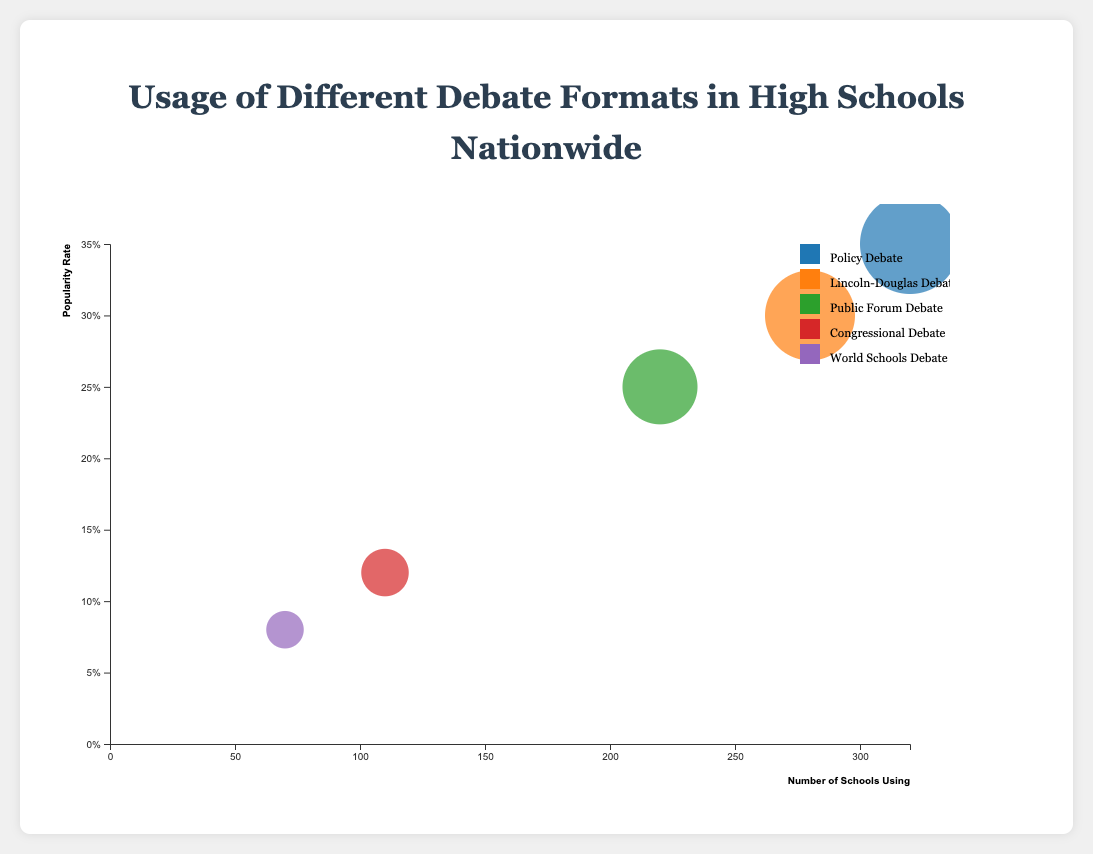What is the title of the bubble chart? Look at the top of the chart where the title is centered and prominently displayed.
Answer: Usage of Different Debate Formats in High Schools Nationwide Which debate format has the highest popularity rate? Identify the bubble positioned at the highest point on the y-axis (representing popularity rate).
Answer: Policy Debate How many regions are summarized in the chart? Review the regions listed under each debate format in the tooltip or data bubbles. Each format lists Northeast, Midwest, South, and West.
Answer: Four Which debate format is used by the fewest number of schools? Locate the bubble furthest to the left on the x-axis, which represents the number of schools using the format.
Answer: World Schools Debate How many schools in the West use Lincoln-Douglas Debate? Look at the tooltip or data bubble for Lincoln-Douglas Debate and identify the number marked next to the 'West' region.
Answer: 60 What is the difference in the number of schools using Policy Debate in the Northeast and Midwest? Subtract the number of schools in the Midwest from the number in the Northeast for the Policy Debate format. Northeast: 100, Midwest: 80. 100 - 80 = 20.
Answer: 20 Which two formats have an equal number of schools using them in the West? Compare the numbers in the West region across all formats and find two formats with the same value.
Answer: Public Forum Debate and Policy Debate What is the average popularity rate of the debate formats? Sum up the popularity rates of all formats and divide by the number of formats. (0.35 + 0.30 + 0.25 + 0.12 + 0.08) / 5 = 0.22.
Answer: 0.22 (or 22%) Which debate format has the largest bubble size, indicating the total regional usage? Identify the largest bubble in the chart, representing the format with the highest total regional usage.
Answer: Policy Debate Is Congressional Debate more popular in the South or the Northeast? Check the number of schools in the South and Northeast for Congressional Debate and compare them. South: 35, Northeast: 25.
Answer: South 